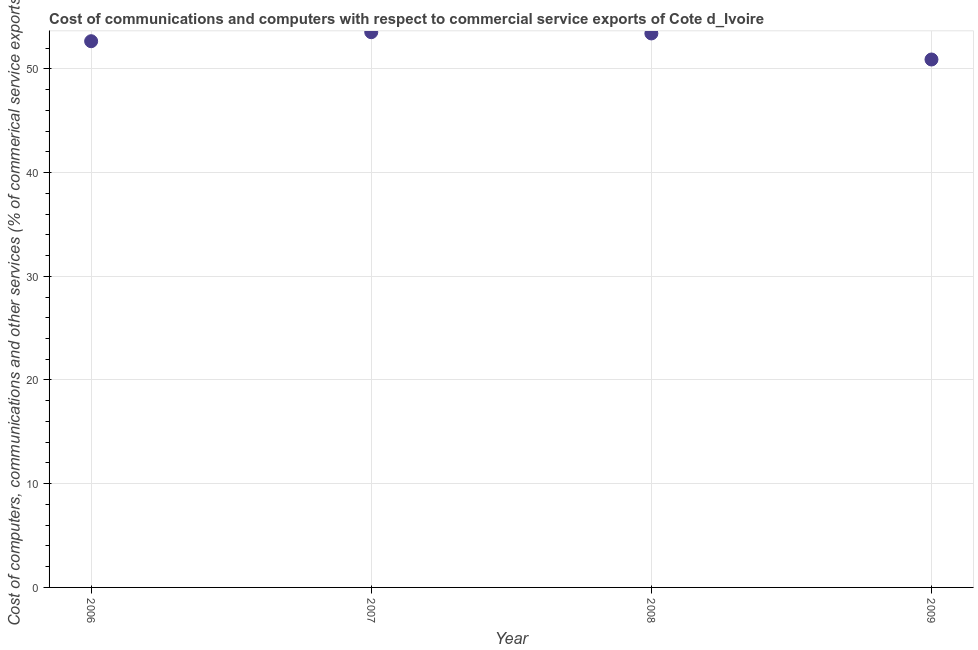What is the  computer and other services in 2009?
Provide a succinct answer. 50.9. Across all years, what is the maximum cost of communications?
Provide a short and direct response. 53.53. Across all years, what is the minimum cost of communications?
Provide a succinct answer. 50.9. What is the sum of the cost of communications?
Ensure brevity in your answer.  210.5. What is the difference between the  computer and other services in 2006 and 2007?
Your answer should be very brief. -0.87. What is the average  computer and other services per year?
Offer a very short reply. 52.62. What is the median  computer and other services?
Keep it short and to the point. 53.04. What is the ratio of the  computer and other services in 2008 to that in 2009?
Make the answer very short. 1.05. Is the cost of communications in 2006 less than that in 2009?
Offer a very short reply. No. Is the difference between the cost of communications in 2007 and 2008 greater than the difference between any two years?
Give a very brief answer. No. What is the difference between the highest and the second highest cost of communications?
Provide a succinct answer. 0.12. Is the sum of the  computer and other services in 2007 and 2009 greater than the maximum  computer and other services across all years?
Your response must be concise. Yes. What is the difference between the highest and the lowest cost of communications?
Your answer should be compact. 2.63. In how many years, is the  computer and other services greater than the average  computer and other services taken over all years?
Give a very brief answer. 3. Does the  computer and other services monotonically increase over the years?
Offer a very short reply. No. How many dotlines are there?
Your answer should be compact. 1. How many years are there in the graph?
Your answer should be compact. 4. Are the values on the major ticks of Y-axis written in scientific E-notation?
Your answer should be very brief. No. Does the graph contain any zero values?
Keep it short and to the point. No. What is the title of the graph?
Your answer should be very brief. Cost of communications and computers with respect to commercial service exports of Cote d_Ivoire. What is the label or title of the X-axis?
Your answer should be very brief. Year. What is the label or title of the Y-axis?
Offer a very short reply. Cost of computers, communications and other services (% of commerical service exports). What is the Cost of computers, communications and other services (% of commerical service exports) in 2006?
Your answer should be compact. 52.66. What is the Cost of computers, communications and other services (% of commerical service exports) in 2007?
Offer a terse response. 53.53. What is the Cost of computers, communications and other services (% of commerical service exports) in 2008?
Your response must be concise. 53.41. What is the Cost of computers, communications and other services (% of commerical service exports) in 2009?
Keep it short and to the point. 50.9. What is the difference between the Cost of computers, communications and other services (% of commerical service exports) in 2006 and 2007?
Your response must be concise. -0.87. What is the difference between the Cost of computers, communications and other services (% of commerical service exports) in 2006 and 2008?
Provide a short and direct response. -0.75. What is the difference between the Cost of computers, communications and other services (% of commerical service exports) in 2006 and 2009?
Ensure brevity in your answer.  1.76. What is the difference between the Cost of computers, communications and other services (% of commerical service exports) in 2007 and 2008?
Keep it short and to the point. 0.12. What is the difference between the Cost of computers, communications and other services (% of commerical service exports) in 2007 and 2009?
Provide a succinct answer. 2.63. What is the difference between the Cost of computers, communications and other services (% of commerical service exports) in 2008 and 2009?
Your response must be concise. 2.51. What is the ratio of the Cost of computers, communications and other services (% of commerical service exports) in 2006 to that in 2008?
Offer a terse response. 0.99. What is the ratio of the Cost of computers, communications and other services (% of commerical service exports) in 2006 to that in 2009?
Your answer should be very brief. 1.03. What is the ratio of the Cost of computers, communications and other services (% of commerical service exports) in 2007 to that in 2008?
Your answer should be compact. 1. What is the ratio of the Cost of computers, communications and other services (% of commerical service exports) in 2007 to that in 2009?
Make the answer very short. 1.05. What is the ratio of the Cost of computers, communications and other services (% of commerical service exports) in 2008 to that in 2009?
Offer a terse response. 1.05. 